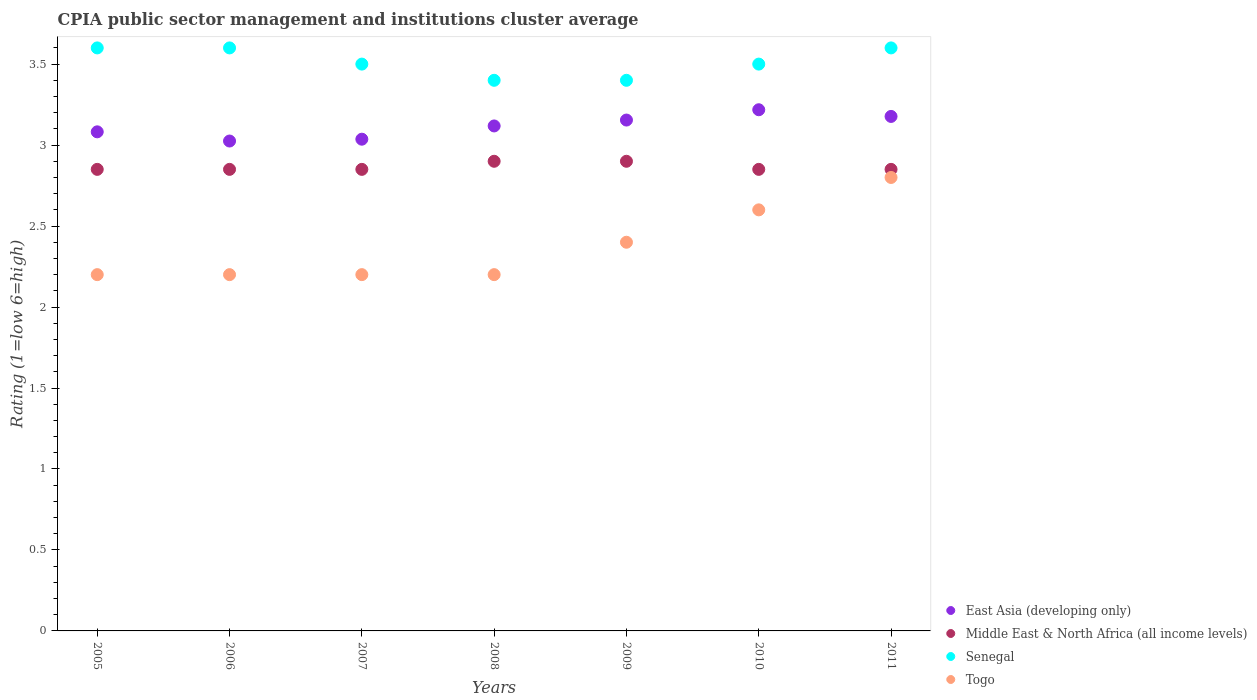Is the number of dotlines equal to the number of legend labels?
Offer a terse response. Yes. What is the CPIA rating in Senegal in 2008?
Offer a very short reply. 3.4. Across all years, what is the maximum CPIA rating in Middle East & North Africa (all income levels)?
Provide a succinct answer. 2.9. Across all years, what is the minimum CPIA rating in Middle East & North Africa (all income levels)?
Your response must be concise. 2.85. In which year was the CPIA rating in Senegal minimum?
Offer a very short reply. 2008. What is the total CPIA rating in Senegal in the graph?
Your answer should be compact. 24.6. What is the difference between the CPIA rating in Togo in 2005 and that in 2011?
Give a very brief answer. -0.6. What is the difference between the CPIA rating in Senegal in 2005 and the CPIA rating in Middle East & North Africa (all income levels) in 2010?
Your answer should be very brief. 0.75. What is the average CPIA rating in Middle East & North Africa (all income levels) per year?
Make the answer very short. 2.86. In the year 2009, what is the difference between the CPIA rating in Senegal and CPIA rating in Middle East & North Africa (all income levels)?
Your answer should be compact. 0.5. Is the difference between the CPIA rating in Senegal in 2006 and 2009 greater than the difference between the CPIA rating in Middle East & North Africa (all income levels) in 2006 and 2009?
Ensure brevity in your answer.  Yes. What is the difference between the highest and the second highest CPIA rating in Togo?
Your response must be concise. 0.2. What is the difference between the highest and the lowest CPIA rating in Togo?
Your answer should be compact. 0.6. Is the sum of the CPIA rating in East Asia (developing only) in 2006 and 2009 greater than the maximum CPIA rating in Middle East & North Africa (all income levels) across all years?
Make the answer very short. Yes. Is it the case that in every year, the sum of the CPIA rating in East Asia (developing only) and CPIA rating in Togo  is greater than the CPIA rating in Middle East & North Africa (all income levels)?
Give a very brief answer. Yes. Is the CPIA rating in Togo strictly less than the CPIA rating in Middle East & North Africa (all income levels) over the years?
Your response must be concise. Yes. How many dotlines are there?
Provide a short and direct response. 4. How many years are there in the graph?
Give a very brief answer. 7. Does the graph contain any zero values?
Offer a terse response. No. How many legend labels are there?
Your answer should be compact. 4. How are the legend labels stacked?
Give a very brief answer. Vertical. What is the title of the graph?
Give a very brief answer. CPIA public sector management and institutions cluster average. Does "Rwanda" appear as one of the legend labels in the graph?
Your response must be concise. No. What is the label or title of the Y-axis?
Offer a terse response. Rating (1=low 6=high). What is the Rating (1=low 6=high) of East Asia (developing only) in 2005?
Provide a short and direct response. 3.08. What is the Rating (1=low 6=high) of Middle East & North Africa (all income levels) in 2005?
Your response must be concise. 2.85. What is the Rating (1=low 6=high) of East Asia (developing only) in 2006?
Keep it short and to the point. 3.02. What is the Rating (1=low 6=high) of Middle East & North Africa (all income levels) in 2006?
Offer a terse response. 2.85. What is the Rating (1=low 6=high) of Senegal in 2006?
Offer a terse response. 3.6. What is the Rating (1=low 6=high) in East Asia (developing only) in 2007?
Ensure brevity in your answer.  3.04. What is the Rating (1=low 6=high) of Middle East & North Africa (all income levels) in 2007?
Provide a succinct answer. 2.85. What is the Rating (1=low 6=high) in East Asia (developing only) in 2008?
Offer a very short reply. 3.12. What is the Rating (1=low 6=high) in Middle East & North Africa (all income levels) in 2008?
Your response must be concise. 2.9. What is the Rating (1=low 6=high) of Togo in 2008?
Your response must be concise. 2.2. What is the Rating (1=low 6=high) of East Asia (developing only) in 2009?
Offer a terse response. 3.15. What is the Rating (1=low 6=high) in Middle East & North Africa (all income levels) in 2009?
Give a very brief answer. 2.9. What is the Rating (1=low 6=high) of Senegal in 2009?
Offer a terse response. 3.4. What is the Rating (1=low 6=high) of East Asia (developing only) in 2010?
Keep it short and to the point. 3.22. What is the Rating (1=low 6=high) in Middle East & North Africa (all income levels) in 2010?
Provide a succinct answer. 2.85. What is the Rating (1=low 6=high) in Senegal in 2010?
Offer a terse response. 3.5. What is the Rating (1=low 6=high) in Togo in 2010?
Your answer should be very brief. 2.6. What is the Rating (1=low 6=high) in East Asia (developing only) in 2011?
Give a very brief answer. 3.18. What is the Rating (1=low 6=high) of Middle East & North Africa (all income levels) in 2011?
Give a very brief answer. 2.85. What is the Rating (1=low 6=high) in Senegal in 2011?
Ensure brevity in your answer.  3.6. Across all years, what is the maximum Rating (1=low 6=high) in East Asia (developing only)?
Your response must be concise. 3.22. Across all years, what is the minimum Rating (1=low 6=high) in East Asia (developing only)?
Your answer should be compact. 3.02. Across all years, what is the minimum Rating (1=low 6=high) in Middle East & North Africa (all income levels)?
Your answer should be compact. 2.85. What is the total Rating (1=low 6=high) of East Asia (developing only) in the graph?
Give a very brief answer. 21.81. What is the total Rating (1=low 6=high) of Middle East & North Africa (all income levels) in the graph?
Ensure brevity in your answer.  20.05. What is the total Rating (1=low 6=high) in Senegal in the graph?
Keep it short and to the point. 24.6. What is the total Rating (1=low 6=high) in Togo in the graph?
Keep it short and to the point. 16.6. What is the difference between the Rating (1=low 6=high) of East Asia (developing only) in 2005 and that in 2006?
Keep it short and to the point. 0.06. What is the difference between the Rating (1=low 6=high) in Senegal in 2005 and that in 2006?
Provide a short and direct response. 0. What is the difference between the Rating (1=low 6=high) of Togo in 2005 and that in 2006?
Your answer should be compact. 0. What is the difference between the Rating (1=low 6=high) in East Asia (developing only) in 2005 and that in 2007?
Give a very brief answer. 0.05. What is the difference between the Rating (1=low 6=high) of Middle East & North Africa (all income levels) in 2005 and that in 2007?
Make the answer very short. 0. What is the difference between the Rating (1=low 6=high) in Senegal in 2005 and that in 2007?
Keep it short and to the point. 0.1. What is the difference between the Rating (1=low 6=high) of East Asia (developing only) in 2005 and that in 2008?
Ensure brevity in your answer.  -0.04. What is the difference between the Rating (1=low 6=high) of East Asia (developing only) in 2005 and that in 2009?
Provide a succinct answer. -0.07. What is the difference between the Rating (1=low 6=high) in Middle East & North Africa (all income levels) in 2005 and that in 2009?
Offer a very short reply. -0.05. What is the difference between the Rating (1=low 6=high) in East Asia (developing only) in 2005 and that in 2010?
Make the answer very short. -0.14. What is the difference between the Rating (1=low 6=high) of Middle East & North Africa (all income levels) in 2005 and that in 2010?
Provide a short and direct response. 0. What is the difference between the Rating (1=low 6=high) in Senegal in 2005 and that in 2010?
Ensure brevity in your answer.  0.1. What is the difference between the Rating (1=low 6=high) of East Asia (developing only) in 2005 and that in 2011?
Offer a terse response. -0.1. What is the difference between the Rating (1=low 6=high) in Middle East & North Africa (all income levels) in 2005 and that in 2011?
Your answer should be very brief. 0. What is the difference between the Rating (1=low 6=high) of Senegal in 2005 and that in 2011?
Give a very brief answer. 0. What is the difference between the Rating (1=low 6=high) in Togo in 2005 and that in 2011?
Provide a succinct answer. -0.6. What is the difference between the Rating (1=low 6=high) in East Asia (developing only) in 2006 and that in 2007?
Your answer should be compact. -0.01. What is the difference between the Rating (1=low 6=high) of Togo in 2006 and that in 2007?
Ensure brevity in your answer.  0. What is the difference between the Rating (1=low 6=high) in East Asia (developing only) in 2006 and that in 2008?
Offer a very short reply. -0.09. What is the difference between the Rating (1=low 6=high) in Middle East & North Africa (all income levels) in 2006 and that in 2008?
Make the answer very short. -0.05. What is the difference between the Rating (1=low 6=high) of East Asia (developing only) in 2006 and that in 2009?
Give a very brief answer. -0.13. What is the difference between the Rating (1=low 6=high) of Senegal in 2006 and that in 2009?
Provide a short and direct response. 0.2. What is the difference between the Rating (1=low 6=high) of East Asia (developing only) in 2006 and that in 2010?
Offer a terse response. -0.19. What is the difference between the Rating (1=low 6=high) of Middle East & North Africa (all income levels) in 2006 and that in 2010?
Provide a succinct answer. 0. What is the difference between the Rating (1=low 6=high) of Senegal in 2006 and that in 2010?
Your answer should be compact. 0.1. What is the difference between the Rating (1=low 6=high) of Togo in 2006 and that in 2010?
Provide a short and direct response. -0.4. What is the difference between the Rating (1=low 6=high) in East Asia (developing only) in 2006 and that in 2011?
Make the answer very short. -0.15. What is the difference between the Rating (1=low 6=high) in Middle East & North Africa (all income levels) in 2006 and that in 2011?
Your answer should be compact. 0. What is the difference between the Rating (1=low 6=high) of Senegal in 2006 and that in 2011?
Give a very brief answer. 0. What is the difference between the Rating (1=low 6=high) in East Asia (developing only) in 2007 and that in 2008?
Offer a very short reply. -0.08. What is the difference between the Rating (1=low 6=high) in Middle East & North Africa (all income levels) in 2007 and that in 2008?
Offer a terse response. -0.05. What is the difference between the Rating (1=low 6=high) in Senegal in 2007 and that in 2008?
Make the answer very short. 0.1. What is the difference between the Rating (1=low 6=high) of East Asia (developing only) in 2007 and that in 2009?
Offer a terse response. -0.12. What is the difference between the Rating (1=low 6=high) in Togo in 2007 and that in 2009?
Offer a terse response. -0.2. What is the difference between the Rating (1=low 6=high) of East Asia (developing only) in 2007 and that in 2010?
Provide a succinct answer. -0.18. What is the difference between the Rating (1=low 6=high) in Middle East & North Africa (all income levels) in 2007 and that in 2010?
Your answer should be compact. 0. What is the difference between the Rating (1=low 6=high) in Togo in 2007 and that in 2010?
Keep it short and to the point. -0.4. What is the difference between the Rating (1=low 6=high) in East Asia (developing only) in 2007 and that in 2011?
Provide a short and direct response. -0.14. What is the difference between the Rating (1=low 6=high) of Middle East & North Africa (all income levels) in 2007 and that in 2011?
Provide a succinct answer. 0. What is the difference between the Rating (1=low 6=high) of Senegal in 2007 and that in 2011?
Give a very brief answer. -0.1. What is the difference between the Rating (1=low 6=high) of Togo in 2007 and that in 2011?
Your answer should be very brief. -0.6. What is the difference between the Rating (1=low 6=high) in East Asia (developing only) in 2008 and that in 2009?
Keep it short and to the point. -0.04. What is the difference between the Rating (1=low 6=high) in Middle East & North Africa (all income levels) in 2008 and that in 2009?
Offer a terse response. 0. What is the difference between the Rating (1=low 6=high) of Middle East & North Africa (all income levels) in 2008 and that in 2010?
Offer a very short reply. 0.05. What is the difference between the Rating (1=low 6=high) in Senegal in 2008 and that in 2010?
Offer a very short reply. -0.1. What is the difference between the Rating (1=low 6=high) of Togo in 2008 and that in 2010?
Keep it short and to the point. -0.4. What is the difference between the Rating (1=low 6=high) in East Asia (developing only) in 2008 and that in 2011?
Offer a very short reply. -0.06. What is the difference between the Rating (1=low 6=high) of Middle East & North Africa (all income levels) in 2008 and that in 2011?
Your response must be concise. 0.05. What is the difference between the Rating (1=low 6=high) of East Asia (developing only) in 2009 and that in 2010?
Ensure brevity in your answer.  -0.06. What is the difference between the Rating (1=low 6=high) of Middle East & North Africa (all income levels) in 2009 and that in 2010?
Make the answer very short. 0.05. What is the difference between the Rating (1=low 6=high) in East Asia (developing only) in 2009 and that in 2011?
Provide a short and direct response. -0.02. What is the difference between the Rating (1=low 6=high) in Middle East & North Africa (all income levels) in 2009 and that in 2011?
Make the answer very short. 0.05. What is the difference between the Rating (1=low 6=high) in Senegal in 2009 and that in 2011?
Your response must be concise. -0.2. What is the difference between the Rating (1=low 6=high) of East Asia (developing only) in 2010 and that in 2011?
Offer a terse response. 0.04. What is the difference between the Rating (1=low 6=high) of Middle East & North Africa (all income levels) in 2010 and that in 2011?
Ensure brevity in your answer.  0. What is the difference between the Rating (1=low 6=high) in Senegal in 2010 and that in 2011?
Offer a very short reply. -0.1. What is the difference between the Rating (1=low 6=high) in Togo in 2010 and that in 2011?
Offer a terse response. -0.2. What is the difference between the Rating (1=low 6=high) in East Asia (developing only) in 2005 and the Rating (1=low 6=high) in Middle East & North Africa (all income levels) in 2006?
Your answer should be compact. 0.23. What is the difference between the Rating (1=low 6=high) in East Asia (developing only) in 2005 and the Rating (1=low 6=high) in Senegal in 2006?
Your response must be concise. -0.52. What is the difference between the Rating (1=low 6=high) of East Asia (developing only) in 2005 and the Rating (1=low 6=high) of Togo in 2006?
Keep it short and to the point. 0.88. What is the difference between the Rating (1=low 6=high) in Middle East & North Africa (all income levels) in 2005 and the Rating (1=low 6=high) in Senegal in 2006?
Your response must be concise. -0.75. What is the difference between the Rating (1=low 6=high) of Middle East & North Africa (all income levels) in 2005 and the Rating (1=low 6=high) of Togo in 2006?
Give a very brief answer. 0.65. What is the difference between the Rating (1=low 6=high) in East Asia (developing only) in 2005 and the Rating (1=low 6=high) in Middle East & North Africa (all income levels) in 2007?
Offer a very short reply. 0.23. What is the difference between the Rating (1=low 6=high) in East Asia (developing only) in 2005 and the Rating (1=low 6=high) in Senegal in 2007?
Provide a short and direct response. -0.42. What is the difference between the Rating (1=low 6=high) of East Asia (developing only) in 2005 and the Rating (1=low 6=high) of Togo in 2007?
Offer a terse response. 0.88. What is the difference between the Rating (1=low 6=high) of Middle East & North Africa (all income levels) in 2005 and the Rating (1=low 6=high) of Senegal in 2007?
Make the answer very short. -0.65. What is the difference between the Rating (1=low 6=high) of Middle East & North Africa (all income levels) in 2005 and the Rating (1=low 6=high) of Togo in 2007?
Offer a very short reply. 0.65. What is the difference between the Rating (1=low 6=high) in East Asia (developing only) in 2005 and the Rating (1=low 6=high) in Middle East & North Africa (all income levels) in 2008?
Your answer should be compact. 0.18. What is the difference between the Rating (1=low 6=high) in East Asia (developing only) in 2005 and the Rating (1=low 6=high) in Senegal in 2008?
Give a very brief answer. -0.32. What is the difference between the Rating (1=low 6=high) in East Asia (developing only) in 2005 and the Rating (1=low 6=high) in Togo in 2008?
Your answer should be compact. 0.88. What is the difference between the Rating (1=low 6=high) of Middle East & North Africa (all income levels) in 2005 and the Rating (1=low 6=high) of Senegal in 2008?
Give a very brief answer. -0.55. What is the difference between the Rating (1=low 6=high) of Middle East & North Africa (all income levels) in 2005 and the Rating (1=low 6=high) of Togo in 2008?
Your response must be concise. 0.65. What is the difference between the Rating (1=low 6=high) of Senegal in 2005 and the Rating (1=low 6=high) of Togo in 2008?
Your response must be concise. 1.4. What is the difference between the Rating (1=low 6=high) in East Asia (developing only) in 2005 and the Rating (1=low 6=high) in Middle East & North Africa (all income levels) in 2009?
Keep it short and to the point. 0.18. What is the difference between the Rating (1=low 6=high) of East Asia (developing only) in 2005 and the Rating (1=low 6=high) of Senegal in 2009?
Keep it short and to the point. -0.32. What is the difference between the Rating (1=low 6=high) in East Asia (developing only) in 2005 and the Rating (1=low 6=high) in Togo in 2009?
Offer a terse response. 0.68. What is the difference between the Rating (1=low 6=high) in Middle East & North Africa (all income levels) in 2005 and the Rating (1=low 6=high) in Senegal in 2009?
Provide a succinct answer. -0.55. What is the difference between the Rating (1=low 6=high) of Middle East & North Africa (all income levels) in 2005 and the Rating (1=low 6=high) of Togo in 2009?
Offer a terse response. 0.45. What is the difference between the Rating (1=low 6=high) in East Asia (developing only) in 2005 and the Rating (1=low 6=high) in Middle East & North Africa (all income levels) in 2010?
Keep it short and to the point. 0.23. What is the difference between the Rating (1=low 6=high) of East Asia (developing only) in 2005 and the Rating (1=low 6=high) of Senegal in 2010?
Offer a very short reply. -0.42. What is the difference between the Rating (1=low 6=high) of East Asia (developing only) in 2005 and the Rating (1=low 6=high) of Togo in 2010?
Your answer should be very brief. 0.48. What is the difference between the Rating (1=low 6=high) in Middle East & North Africa (all income levels) in 2005 and the Rating (1=low 6=high) in Senegal in 2010?
Offer a very short reply. -0.65. What is the difference between the Rating (1=low 6=high) of Senegal in 2005 and the Rating (1=low 6=high) of Togo in 2010?
Your response must be concise. 1. What is the difference between the Rating (1=low 6=high) in East Asia (developing only) in 2005 and the Rating (1=low 6=high) in Middle East & North Africa (all income levels) in 2011?
Provide a short and direct response. 0.23. What is the difference between the Rating (1=low 6=high) of East Asia (developing only) in 2005 and the Rating (1=low 6=high) of Senegal in 2011?
Provide a succinct answer. -0.52. What is the difference between the Rating (1=low 6=high) of East Asia (developing only) in 2005 and the Rating (1=low 6=high) of Togo in 2011?
Provide a succinct answer. 0.28. What is the difference between the Rating (1=low 6=high) in Middle East & North Africa (all income levels) in 2005 and the Rating (1=low 6=high) in Senegal in 2011?
Ensure brevity in your answer.  -0.75. What is the difference between the Rating (1=low 6=high) in Senegal in 2005 and the Rating (1=low 6=high) in Togo in 2011?
Give a very brief answer. 0.8. What is the difference between the Rating (1=low 6=high) in East Asia (developing only) in 2006 and the Rating (1=low 6=high) in Middle East & North Africa (all income levels) in 2007?
Give a very brief answer. 0.17. What is the difference between the Rating (1=low 6=high) of East Asia (developing only) in 2006 and the Rating (1=low 6=high) of Senegal in 2007?
Offer a very short reply. -0.47. What is the difference between the Rating (1=low 6=high) in East Asia (developing only) in 2006 and the Rating (1=low 6=high) in Togo in 2007?
Your answer should be compact. 0.82. What is the difference between the Rating (1=low 6=high) of Middle East & North Africa (all income levels) in 2006 and the Rating (1=low 6=high) of Senegal in 2007?
Give a very brief answer. -0.65. What is the difference between the Rating (1=low 6=high) of Middle East & North Africa (all income levels) in 2006 and the Rating (1=low 6=high) of Togo in 2007?
Make the answer very short. 0.65. What is the difference between the Rating (1=low 6=high) of East Asia (developing only) in 2006 and the Rating (1=low 6=high) of Senegal in 2008?
Offer a very short reply. -0.38. What is the difference between the Rating (1=low 6=high) in East Asia (developing only) in 2006 and the Rating (1=low 6=high) in Togo in 2008?
Ensure brevity in your answer.  0.82. What is the difference between the Rating (1=low 6=high) in Middle East & North Africa (all income levels) in 2006 and the Rating (1=low 6=high) in Senegal in 2008?
Keep it short and to the point. -0.55. What is the difference between the Rating (1=low 6=high) of Middle East & North Africa (all income levels) in 2006 and the Rating (1=low 6=high) of Togo in 2008?
Your response must be concise. 0.65. What is the difference between the Rating (1=low 6=high) of Senegal in 2006 and the Rating (1=low 6=high) of Togo in 2008?
Make the answer very short. 1.4. What is the difference between the Rating (1=low 6=high) in East Asia (developing only) in 2006 and the Rating (1=low 6=high) in Middle East & North Africa (all income levels) in 2009?
Give a very brief answer. 0.12. What is the difference between the Rating (1=low 6=high) in East Asia (developing only) in 2006 and the Rating (1=low 6=high) in Senegal in 2009?
Your response must be concise. -0.38. What is the difference between the Rating (1=low 6=high) of Middle East & North Africa (all income levels) in 2006 and the Rating (1=low 6=high) of Senegal in 2009?
Your response must be concise. -0.55. What is the difference between the Rating (1=low 6=high) in Middle East & North Africa (all income levels) in 2006 and the Rating (1=low 6=high) in Togo in 2009?
Offer a terse response. 0.45. What is the difference between the Rating (1=low 6=high) in East Asia (developing only) in 2006 and the Rating (1=low 6=high) in Middle East & North Africa (all income levels) in 2010?
Make the answer very short. 0.17. What is the difference between the Rating (1=low 6=high) of East Asia (developing only) in 2006 and the Rating (1=low 6=high) of Senegal in 2010?
Keep it short and to the point. -0.47. What is the difference between the Rating (1=low 6=high) of East Asia (developing only) in 2006 and the Rating (1=low 6=high) of Togo in 2010?
Provide a succinct answer. 0.42. What is the difference between the Rating (1=low 6=high) in Middle East & North Africa (all income levels) in 2006 and the Rating (1=low 6=high) in Senegal in 2010?
Your answer should be compact. -0.65. What is the difference between the Rating (1=low 6=high) in Senegal in 2006 and the Rating (1=low 6=high) in Togo in 2010?
Make the answer very short. 1. What is the difference between the Rating (1=low 6=high) of East Asia (developing only) in 2006 and the Rating (1=low 6=high) of Middle East & North Africa (all income levels) in 2011?
Your answer should be very brief. 0.17. What is the difference between the Rating (1=low 6=high) of East Asia (developing only) in 2006 and the Rating (1=low 6=high) of Senegal in 2011?
Make the answer very short. -0.57. What is the difference between the Rating (1=low 6=high) of East Asia (developing only) in 2006 and the Rating (1=low 6=high) of Togo in 2011?
Your answer should be compact. 0.23. What is the difference between the Rating (1=low 6=high) in Middle East & North Africa (all income levels) in 2006 and the Rating (1=low 6=high) in Senegal in 2011?
Offer a terse response. -0.75. What is the difference between the Rating (1=low 6=high) in East Asia (developing only) in 2007 and the Rating (1=low 6=high) in Middle East & North Africa (all income levels) in 2008?
Provide a short and direct response. 0.14. What is the difference between the Rating (1=low 6=high) in East Asia (developing only) in 2007 and the Rating (1=low 6=high) in Senegal in 2008?
Offer a terse response. -0.36. What is the difference between the Rating (1=low 6=high) in East Asia (developing only) in 2007 and the Rating (1=low 6=high) in Togo in 2008?
Provide a short and direct response. 0.84. What is the difference between the Rating (1=low 6=high) of Middle East & North Africa (all income levels) in 2007 and the Rating (1=low 6=high) of Senegal in 2008?
Provide a succinct answer. -0.55. What is the difference between the Rating (1=low 6=high) of Middle East & North Africa (all income levels) in 2007 and the Rating (1=low 6=high) of Togo in 2008?
Keep it short and to the point. 0.65. What is the difference between the Rating (1=low 6=high) in East Asia (developing only) in 2007 and the Rating (1=low 6=high) in Middle East & North Africa (all income levels) in 2009?
Your response must be concise. 0.14. What is the difference between the Rating (1=low 6=high) in East Asia (developing only) in 2007 and the Rating (1=low 6=high) in Senegal in 2009?
Provide a short and direct response. -0.36. What is the difference between the Rating (1=low 6=high) of East Asia (developing only) in 2007 and the Rating (1=low 6=high) of Togo in 2009?
Provide a short and direct response. 0.64. What is the difference between the Rating (1=low 6=high) of Middle East & North Africa (all income levels) in 2007 and the Rating (1=low 6=high) of Senegal in 2009?
Ensure brevity in your answer.  -0.55. What is the difference between the Rating (1=low 6=high) of Middle East & North Africa (all income levels) in 2007 and the Rating (1=low 6=high) of Togo in 2009?
Ensure brevity in your answer.  0.45. What is the difference between the Rating (1=low 6=high) of East Asia (developing only) in 2007 and the Rating (1=low 6=high) of Middle East & North Africa (all income levels) in 2010?
Offer a terse response. 0.19. What is the difference between the Rating (1=low 6=high) in East Asia (developing only) in 2007 and the Rating (1=low 6=high) in Senegal in 2010?
Provide a succinct answer. -0.46. What is the difference between the Rating (1=low 6=high) in East Asia (developing only) in 2007 and the Rating (1=low 6=high) in Togo in 2010?
Your response must be concise. 0.44. What is the difference between the Rating (1=low 6=high) in Middle East & North Africa (all income levels) in 2007 and the Rating (1=low 6=high) in Senegal in 2010?
Ensure brevity in your answer.  -0.65. What is the difference between the Rating (1=low 6=high) in Middle East & North Africa (all income levels) in 2007 and the Rating (1=low 6=high) in Togo in 2010?
Your response must be concise. 0.25. What is the difference between the Rating (1=low 6=high) of East Asia (developing only) in 2007 and the Rating (1=low 6=high) of Middle East & North Africa (all income levels) in 2011?
Offer a very short reply. 0.19. What is the difference between the Rating (1=low 6=high) in East Asia (developing only) in 2007 and the Rating (1=low 6=high) in Senegal in 2011?
Provide a short and direct response. -0.56. What is the difference between the Rating (1=low 6=high) in East Asia (developing only) in 2007 and the Rating (1=low 6=high) in Togo in 2011?
Offer a very short reply. 0.24. What is the difference between the Rating (1=low 6=high) of Middle East & North Africa (all income levels) in 2007 and the Rating (1=low 6=high) of Senegal in 2011?
Ensure brevity in your answer.  -0.75. What is the difference between the Rating (1=low 6=high) in East Asia (developing only) in 2008 and the Rating (1=low 6=high) in Middle East & North Africa (all income levels) in 2009?
Your response must be concise. 0.22. What is the difference between the Rating (1=low 6=high) in East Asia (developing only) in 2008 and the Rating (1=low 6=high) in Senegal in 2009?
Ensure brevity in your answer.  -0.28. What is the difference between the Rating (1=low 6=high) in East Asia (developing only) in 2008 and the Rating (1=low 6=high) in Togo in 2009?
Ensure brevity in your answer.  0.72. What is the difference between the Rating (1=low 6=high) in Senegal in 2008 and the Rating (1=low 6=high) in Togo in 2009?
Offer a very short reply. 1. What is the difference between the Rating (1=low 6=high) of East Asia (developing only) in 2008 and the Rating (1=low 6=high) of Middle East & North Africa (all income levels) in 2010?
Ensure brevity in your answer.  0.27. What is the difference between the Rating (1=low 6=high) of East Asia (developing only) in 2008 and the Rating (1=low 6=high) of Senegal in 2010?
Offer a very short reply. -0.38. What is the difference between the Rating (1=low 6=high) in East Asia (developing only) in 2008 and the Rating (1=low 6=high) in Togo in 2010?
Keep it short and to the point. 0.52. What is the difference between the Rating (1=low 6=high) of Middle East & North Africa (all income levels) in 2008 and the Rating (1=low 6=high) of Togo in 2010?
Offer a very short reply. 0.3. What is the difference between the Rating (1=low 6=high) of East Asia (developing only) in 2008 and the Rating (1=low 6=high) of Middle East & North Africa (all income levels) in 2011?
Give a very brief answer. 0.27. What is the difference between the Rating (1=low 6=high) in East Asia (developing only) in 2008 and the Rating (1=low 6=high) in Senegal in 2011?
Provide a succinct answer. -0.48. What is the difference between the Rating (1=low 6=high) in East Asia (developing only) in 2008 and the Rating (1=low 6=high) in Togo in 2011?
Make the answer very short. 0.32. What is the difference between the Rating (1=low 6=high) in East Asia (developing only) in 2009 and the Rating (1=low 6=high) in Middle East & North Africa (all income levels) in 2010?
Give a very brief answer. 0.3. What is the difference between the Rating (1=low 6=high) of East Asia (developing only) in 2009 and the Rating (1=low 6=high) of Senegal in 2010?
Your answer should be compact. -0.35. What is the difference between the Rating (1=low 6=high) in East Asia (developing only) in 2009 and the Rating (1=low 6=high) in Togo in 2010?
Ensure brevity in your answer.  0.55. What is the difference between the Rating (1=low 6=high) of Middle East & North Africa (all income levels) in 2009 and the Rating (1=low 6=high) of Senegal in 2010?
Keep it short and to the point. -0.6. What is the difference between the Rating (1=low 6=high) of Senegal in 2009 and the Rating (1=low 6=high) of Togo in 2010?
Provide a succinct answer. 0.8. What is the difference between the Rating (1=low 6=high) of East Asia (developing only) in 2009 and the Rating (1=low 6=high) of Middle East & North Africa (all income levels) in 2011?
Make the answer very short. 0.3. What is the difference between the Rating (1=low 6=high) of East Asia (developing only) in 2009 and the Rating (1=low 6=high) of Senegal in 2011?
Give a very brief answer. -0.45. What is the difference between the Rating (1=low 6=high) in East Asia (developing only) in 2009 and the Rating (1=low 6=high) in Togo in 2011?
Keep it short and to the point. 0.35. What is the difference between the Rating (1=low 6=high) in Middle East & North Africa (all income levels) in 2009 and the Rating (1=low 6=high) in Senegal in 2011?
Provide a succinct answer. -0.7. What is the difference between the Rating (1=low 6=high) in East Asia (developing only) in 2010 and the Rating (1=low 6=high) in Middle East & North Africa (all income levels) in 2011?
Keep it short and to the point. 0.37. What is the difference between the Rating (1=low 6=high) in East Asia (developing only) in 2010 and the Rating (1=low 6=high) in Senegal in 2011?
Ensure brevity in your answer.  -0.38. What is the difference between the Rating (1=low 6=high) in East Asia (developing only) in 2010 and the Rating (1=low 6=high) in Togo in 2011?
Provide a succinct answer. 0.42. What is the difference between the Rating (1=low 6=high) of Middle East & North Africa (all income levels) in 2010 and the Rating (1=low 6=high) of Senegal in 2011?
Keep it short and to the point. -0.75. What is the difference between the Rating (1=low 6=high) of Middle East & North Africa (all income levels) in 2010 and the Rating (1=low 6=high) of Togo in 2011?
Keep it short and to the point. 0.05. What is the average Rating (1=low 6=high) in East Asia (developing only) per year?
Your response must be concise. 3.12. What is the average Rating (1=low 6=high) in Middle East & North Africa (all income levels) per year?
Ensure brevity in your answer.  2.86. What is the average Rating (1=low 6=high) of Senegal per year?
Ensure brevity in your answer.  3.51. What is the average Rating (1=low 6=high) of Togo per year?
Make the answer very short. 2.37. In the year 2005, what is the difference between the Rating (1=low 6=high) in East Asia (developing only) and Rating (1=low 6=high) in Middle East & North Africa (all income levels)?
Provide a succinct answer. 0.23. In the year 2005, what is the difference between the Rating (1=low 6=high) of East Asia (developing only) and Rating (1=low 6=high) of Senegal?
Provide a succinct answer. -0.52. In the year 2005, what is the difference between the Rating (1=low 6=high) in East Asia (developing only) and Rating (1=low 6=high) in Togo?
Your answer should be very brief. 0.88. In the year 2005, what is the difference between the Rating (1=low 6=high) of Middle East & North Africa (all income levels) and Rating (1=low 6=high) of Senegal?
Make the answer very short. -0.75. In the year 2005, what is the difference between the Rating (1=low 6=high) of Middle East & North Africa (all income levels) and Rating (1=low 6=high) of Togo?
Give a very brief answer. 0.65. In the year 2006, what is the difference between the Rating (1=low 6=high) in East Asia (developing only) and Rating (1=low 6=high) in Middle East & North Africa (all income levels)?
Your answer should be compact. 0.17. In the year 2006, what is the difference between the Rating (1=low 6=high) in East Asia (developing only) and Rating (1=low 6=high) in Senegal?
Give a very brief answer. -0.57. In the year 2006, what is the difference between the Rating (1=low 6=high) of East Asia (developing only) and Rating (1=low 6=high) of Togo?
Keep it short and to the point. 0.82. In the year 2006, what is the difference between the Rating (1=low 6=high) in Middle East & North Africa (all income levels) and Rating (1=low 6=high) in Senegal?
Your response must be concise. -0.75. In the year 2006, what is the difference between the Rating (1=low 6=high) in Middle East & North Africa (all income levels) and Rating (1=low 6=high) in Togo?
Ensure brevity in your answer.  0.65. In the year 2007, what is the difference between the Rating (1=low 6=high) in East Asia (developing only) and Rating (1=low 6=high) in Middle East & North Africa (all income levels)?
Provide a short and direct response. 0.19. In the year 2007, what is the difference between the Rating (1=low 6=high) of East Asia (developing only) and Rating (1=low 6=high) of Senegal?
Make the answer very short. -0.46. In the year 2007, what is the difference between the Rating (1=low 6=high) in East Asia (developing only) and Rating (1=low 6=high) in Togo?
Give a very brief answer. 0.84. In the year 2007, what is the difference between the Rating (1=low 6=high) of Middle East & North Africa (all income levels) and Rating (1=low 6=high) of Senegal?
Provide a succinct answer. -0.65. In the year 2007, what is the difference between the Rating (1=low 6=high) in Middle East & North Africa (all income levels) and Rating (1=low 6=high) in Togo?
Your response must be concise. 0.65. In the year 2007, what is the difference between the Rating (1=low 6=high) in Senegal and Rating (1=low 6=high) in Togo?
Provide a short and direct response. 1.3. In the year 2008, what is the difference between the Rating (1=low 6=high) in East Asia (developing only) and Rating (1=low 6=high) in Middle East & North Africa (all income levels)?
Give a very brief answer. 0.22. In the year 2008, what is the difference between the Rating (1=low 6=high) in East Asia (developing only) and Rating (1=low 6=high) in Senegal?
Provide a short and direct response. -0.28. In the year 2008, what is the difference between the Rating (1=low 6=high) of East Asia (developing only) and Rating (1=low 6=high) of Togo?
Your answer should be compact. 0.92. In the year 2008, what is the difference between the Rating (1=low 6=high) of Middle East & North Africa (all income levels) and Rating (1=low 6=high) of Senegal?
Make the answer very short. -0.5. In the year 2008, what is the difference between the Rating (1=low 6=high) in Senegal and Rating (1=low 6=high) in Togo?
Your answer should be very brief. 1.2. In the year 2009, what is the difference between the Rating (1=low 6=high) in East Asia (developing only) and Rating (1=low 6=high) in Middle East & North Africa (all income levels)?
Your response must be concise. 0.25. In the year 2009, what is the difference between the Rating (1=low 6=high) in East Asia (developing only) and Rating (1=low 6=high) in Senegal?
Make the answer very short. -0.25. In the year 2009, what is the difference between the Rating (1=low 6=high) in East Asia (developing only) and Rating (1=low 6=high) in Togo?
Make the answer very short. 0.75. In the year 2009, what is the difference between the Rating (1=low 6=high) in Middle East & North Africa (all income levels) and Rating (1=low 6=high) in Senegal?
Your response must be concise. -0.5. In the year 2009, what is the difference between the Rating (1=low 6=high) of Senegal and Rating (1=low 6=high) of Togo?
Your response must be concise. 1. In the year 2010, what is the difference between the Rating (1=low 6=high) in East Asia (developing only) and Rating (1=low 6=high) in Middle East & North Africa (all income levels)?
Your answer should be very brief. 0.37. In the year 2010, what is the difference between the Rating (1=low 6=high) of East Asia (developing only) and Rating (1=low 6=high) of Senegal?
Your answer should be compact. -0.28. In the year 2010, what is the difference between the Rating (1=low 6=high) of East Asia (developing only) and Rating (1=low 6=high) of Togo?
Give a very brief answer. 0.62. In the year 2010, what is the difference between the Rating (1=low 6=high) of Middle East & North Africa (all income levels) and Rating (1=low 6=high) of Senegal?
Your answer should be compact. -0.65. In the year 2011, what is the difference between the Rating (1=low 6=high) in East Asia (developing only) and Rating (1=low 6=high) in Middle East & North Africa (all income levels)?
Ensure brevity in your answer.  0.33. In the year 2011, what is the difference between the Rating (1=low 6=high) in East Asia (developing only) and Rating (1=low 6=high) in Senegal?
Ensure brevity in your answer.  -0.42. In the year 2011, what is the difference between the Rating (1=low 6=high) of East Asia (developing only) and Rating (1=low 6=high) of Togo?
Provide a short and direct response. 0.38. In the year 2011, what is the difference between the Rating (1=low 6=high) in Middle East & North Africa (all income levels) and Rating (1=low 6=high) in Senegal?
Keep it short and to the point. -0.75. What is the ratio of the Rating (1=low 6=high) in East Asia (developing only) in 2005 to that in 2006?
Provide a succinct answer. 1.02. What is the ratio of the Rating (1=low 6=high) of Middle East & North Africa (all income levels) in 2005 to that in 2006?
Provide a short and direct response. 1. What is the ratio of the Rating (1=low 6=high) of Togo in 2005 to that in 2006?
Make the answer very short. 1. What is the ratio of the Rating (1=low 6=high) of East Asia (developing only) in 2005 to that in 2007?
Make the answer very short. 1.01. What is the ratio of the Rating (1=low 6=high) of Middle East & North Africa (all income levels) in 2005 to that in 2007?
Provide a short and direct response. 1. What is the ratio of the Rating (1=low 6=high) in Senegal in 2005 to that in 2007?
Your answer should be compact. 1.03. What is the ratio of the Rating (1=low 6=high) of East Asia (developing only) in 2005 to that in 2008?
Provide a succinct answer. 0.99. What is the ratio of the Rating (1=low 6=high) of Middle East & North Africa (all income levels) in 2005 to that in 2008?
Offer a very short reply. 0.98. What is the ratio of the Rating (1=low 6=high) of Senegal in 2005 to that in 2008?
Provide a short and direct response. 1.06. What is the ratio of the Rating (1=low 6=high) of East Asia (developing only) in 2005 to that in 2009?
Provide a short and direct response. 0.98. What is the ratio of the Rating (1=low 6=high) in Middle East & North Africa (all income levels) in 2005 to that in 2009?
Ensure brevity in your answer.  0.98. What is the ratio of the Rating (1=low 6=high) of Senegal in 2005 to that in 2009?
Offer a very short reply. 1.06. What is the ratio of the Rating (1=low 6=high) in Togo in 2005 to that in 2009?
Ensure brevity in your answer.  0.92. What is the ratio of the Rating (1=low 6=high) in East Asia (developing only) in 2005 to that in 2010?
Your response must be concise. 0.96. What is the ratio of the Rating (1=low 6=high) in Middle East & North Africa (all income levels) in 2005 to that in 2010?
Your answer should be compact. 1. What is the ratio of the Rating (1=low 6=high) of Senegal in 2005 to that in 2010?
Keep it short and to the point. 1.03. What is the ratio of the Rating (1=low 6=high) of Togo in 2005 to that in 2010?
Offer a very short reply. 0.85. What is the ratio of the Rating (1=low 6=high) in East Asia (developing only) in 2005 to that in 2011?
Give a very brief answer. 0.97. What is the ratio of the Rating (1=low 6=high) in Togo in 2005 to that in 2011?
Your answer should be very brief. 0.79. What is the ratio of the Rating (1=low 6=high) of Middle East & North Africa (all income levels) in 2006 to that in 2007?
Provide a short and direct response. 1. What is the ratio of the Rating (1=low 6=high) in Senegal in 2006 to that in 2007?
Give a very brief answer. 1.03. What is the ratio of the Rating (1=low 6=high) in East Asia (developing only) in 2006 to that in 2008?
Keep it short and to the point. 0.97. What is the ratio of the Rating (1=low 6=high) of Middle East & North Africa (all income levels) in 2006 to that in 2008?
Keep it short and to the point. 0.98. What is the ratio of the Rating (1=low 6=high) of Senegal in 2006 to that in 2008?
Keep it short and to the point. 1.06. What is the ratio of the Rating (1=low 6=high) in Togo in 2006 to that in 2008?
Provide a succinct answer. 1. What is the ratio of the Rating (1=low 6=high) of East Asia (developing only) in 2006 to that in 2009?
Your response must be concise. 0.96. What is the ratio of the Rating (1=low 6=high) of Middle East & North Africa (all income levels) in 2006 to that in 2009?
Make the answer very short. 0.98. What is the ratio of the Rating (1=low 6=high) in Senegal in 2006 to that in 2009?
Offer a very short reply. 1.06. What is the ratio of the Rating (1=low 6=high) of Togo in 2006 to that in 2009?
Make the answer very short. 0.92. What is the ratio of the Rating (1=low 6=high) in Middle East & North Africa (all income levels) in 2006 to that in 2010?
Keep it short and to the point. 1. What is the ratio of the Rating (1=low 6=high) in Senegal in 2006 to that in 2010?
Offer a terse response. 1.03. What is the ratio of the Rating (1=low 6=high) in Togo in 2006 to that in 2010?
Provide a succinct answer. 0.85. What is the ratio of the Rating (1=low 6=high) in East Asia (developing only) in 2006 to that in 2011?
Your answer should be very brief. 0.95. What is the ratio of the Rating (1=low 6=high) in Togo in 2006 to that in 2011?
Provide a short and direct response. 0.79. What is the ratio of the Rating (1=low 6=high) in East Asia (developing only) in 2007 to that in 2008?
Offer a very short reply. 0.97. What is the ratio of the Rating (1=low 6=high) in Middle East & North Africa (all income levels) in 2007 to that in 2008?
Your response must be concise. 0.98. What is the ratio of the Rating (1=low 6=high) in Senegal in 2007 to that in 2008?
Offer a terse response. 1.03. What is the ratio of the Rating (1=low 6=high) of East Asia (developing only) in 2007 to that in 2009?
Offer a terse response. 0.96. What is the ratio of the Rating (1=low 6=high) in Middle East & North Africa (all income levels) in 2007 to that in 2009?
Offer a very short reply. 0.98. What is the ratio of the Rating (1=low 6=high) of Senegal in 2007 to that in 2009?
Provide a succinct answer. 1.03. What is the ratio of the Rating (1=low 6=high) in Togo in 2007 to that in 2009?
Your response must be concise. 0.92. What is the ratio of the Rating (1=low 6=high) of East Asia (developing only) in 2007 to that in 2010?
Provide a succinct answer. 0.94. What is the ratio of the Rating (1=low 6=high) of Senegal in 2007 to that in 2010?
Your answer should be compact. 1. What is the ratio of the Rating (1=low 6=high) in Togo in 2007 to that in 2010?
Provide a short and direct response. 0.85. What is the ratio of the Rating (1=low 6=high) in East Asia (developing only) in 2007 to that in 2011?
Offer a very short reply. 0.96. What is the ratio of the Rating (1=low 6=high) in Middle East & North Africa (all income levels) in 2007 to that in 2011?
Your response must be concise. 1. What is the ratio of the Rating (1=low 6=high) in Senegal in 2007 to that in 2011?
Provide a succinct answer. 0.97. What is the ratio of the Rating (1=low 6=high) of Togo in 2007 to that in 2011?
Offer a terse response. 0.79. What is the ratio of the Rating (1=low 6=high) in Togo in 2008 to that in 2009?
Keep it short and to the point. 0.92. What is the ratio of the Rating (1=low 6=high) of East Asia (developing only) in 2008 to that in 2010?
Ensure brevity in your answer.  0.97. What is the ratio of the Rating (1=low 6=high) of Middle East & North Africa (all income levels) in 2008 to that in 2010?
Offer a very short reply. 1.02. What is the ratio of the Rating (1=low 6=high) in Senegal in 2008 to that in 2010?
Keep it short and to the point. 0.97. What is the ratio of the Rating (1=low 6=high) in Togo in 2008 to that in 2010?
Provide a succinct answer. 0.85. What is the ratio of the Rating (1=low 6=high) of East Asia (developing only) in 2008 to that in 2011?
Provide a short and direct response. 0.98. What is the ratio of the Rating (1=low 6=high) in Middle East & North Africa (all income levels) in 2008 to that in 2011?
Give a very brief answer. 1.02. What is the ratio of the Rating (1=low 6=high) of Senegal in 2008 to that in 2011?
Give a very brief answer. 0.94. What is the ratio of the Rating (1=low 6=high) in Togo in 2008 to that in 2011?
Your response must be concise. 0.79. What is the ratio of the Rating (1=low 6=high) in East Asia (developing only) in 2009 to that in 2010?
Give a very brief answer. 0.98. What is the ratio of the Rating (1=low 6=high) in Middle East & North Africa (all income levels) in 2009 to that in 2010?
Make the answer very short. 1.02. What is the ratio of the Rating (1=low 6=high) of Senegal in 2009 to that in 2010?
Ensure brevity in your answer.  0.97. What is the ratio of the Rating (1=low 6=high) in Togo in 2009 to that in 2010?
Offer a very short reply. 0.92. What is the ratio of the Rating (1=low 6=high) in East Asia (developing only) in 2009 to that in 2011?
Offer a very short reply. 0.99. What is the ratio of the Rating (1=low 6=high) of Middle East & North Africa (all income levels) in 2009 to that in 2011?
Keep it short and to the point. 1.02. What is the ratio of the Rating (1=low 6=high) of Senegal in 2009 to that in 2011?
Offer a very short reply. 0.94. What is the ratio of the Rating (1=low 6=high) in Middle East & North Africa (all income levels) in 2010 to that in 2011?
Keep it short and to the point. 1. What is the ratio of the Rating (1=low 6=high) of Senegal in 2010 to that in 2011?
Provide a succinct answer. 0.97. What is the ratio of the Rating (1=low 6=high) of Togo in 2010 to that in 2011?
Keep it short and to the point. 0.93. What is the difference between the highest and the second highest Rating (1=low 6=high) of East Asia (developing only)?
Give a very brief answer. 0.04. What is the difference between the highest and the second highest Rating (1=low 6=high) in Middle East & North Africa (all income levels)?
Provide a succinct answer. 0. What is the difference between the highest and the lowest Rating (1=low 6=high) in East Asia (developing only)?
Your answer should be very brief. 0.19. What is the difference between the highest and the lowest Rating (1=low 6=high) of Senegal?
Offer a very short reply. 0.2. What is the difference between the highest and the lowest Rating (1=low 6=high) of Togo?
Your answer should be compact. 0.6. 